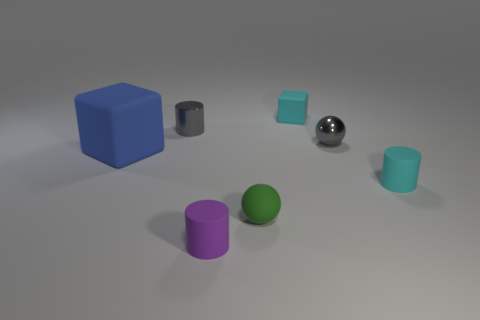What might be the function of these objects if they were real? If these objects were real, they could be various types of containers or simple geometric shapes used for educational purposes, like teaching about volumes and geometry in a classroom setting. Could the size of the objects give us a clue about their use? Yes, the varying sizes could indicate different storage capacities if they are containers, or they might be proportioned to illustrate mathematical ratios and scaling if used for educational demonstrations. 